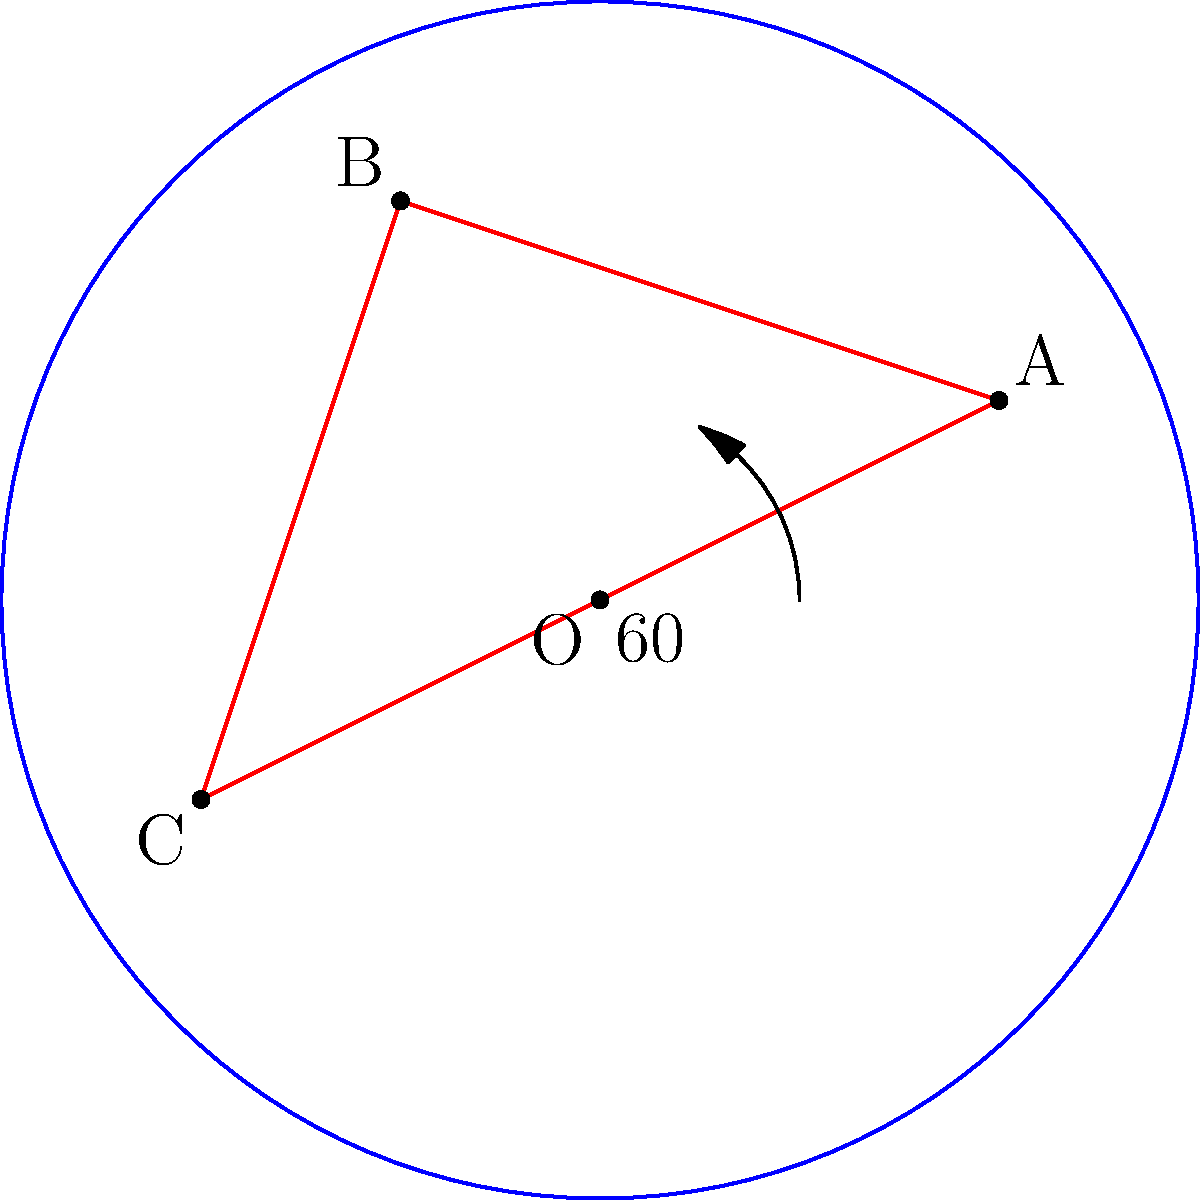In your bookstore's fantasy section, you've created a magical display featuring a rotating creature. The creature is represented by triangle ABC with vertices A(2,1), B(-1,2), and C(-2,-1). If the creature rotates 60° counterclockwise around the origin O, what are the coordinates of point A after the rotation? To find the coordinates of point A after a 60° counterclockwise rotation around the origin, we can follow these steps:

1. Recall the rotation formula for a point (x,y) rotated by an angle θ counterclockwise around the origin:
   $x' = x \cos θ - y \sin θ$
   $y' = x \sin θ + y \cos θ$

2. In this case, θ = 60°, x = 2, and y = 1

3. Calculate the values of $\cos 60°$ and $\sin 60°$:
   $\cos 60° = \frac{1}{2}$
   $\sin 60° = \frac{\sqrt{3}}{2}$

4. Substitute these values into the rotation formulas:
   $x' = 2 \cdot \frac{1}{2} - 1 \cdot \frac{\sqrt{3}}{2} = 1 - \frac{\sqrt{3}}{2}$
   $y' = 2 \cdot \frac{\sqrt{3}}{2} + 1 \cdot \frac{1}{2} = \sqrt{3} + \frac{1}{2}$

5. Simplify:
   $x' = 1 - \frac{\sqrt{3}}{2}$
   $y' = \frac{\sqrt{3}}{2} + \frac{1}{2} = \frac{\sqrt{3} + 1}{2}$

Therefore, after the 60° counterclockwise rotation, point A will have coordinates $(1 - \frac{\sqrt{3}}{2}, \frac{\sqrt{3} + 1}{2})$.
Answer: $(1 - \frac{\sqrt{3}}{2}, \frac{\sqrt{3} + 1}{2})$ 